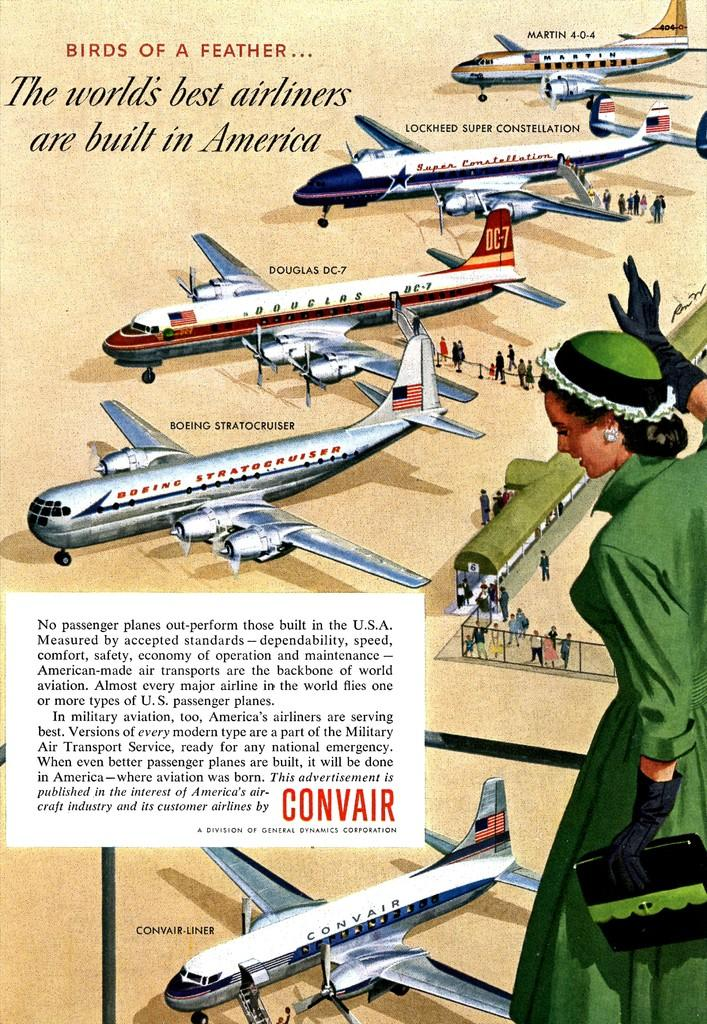<image>
Offer a succinct explanation of the picture presented. An old advertisement for Convair with information on their planes. 